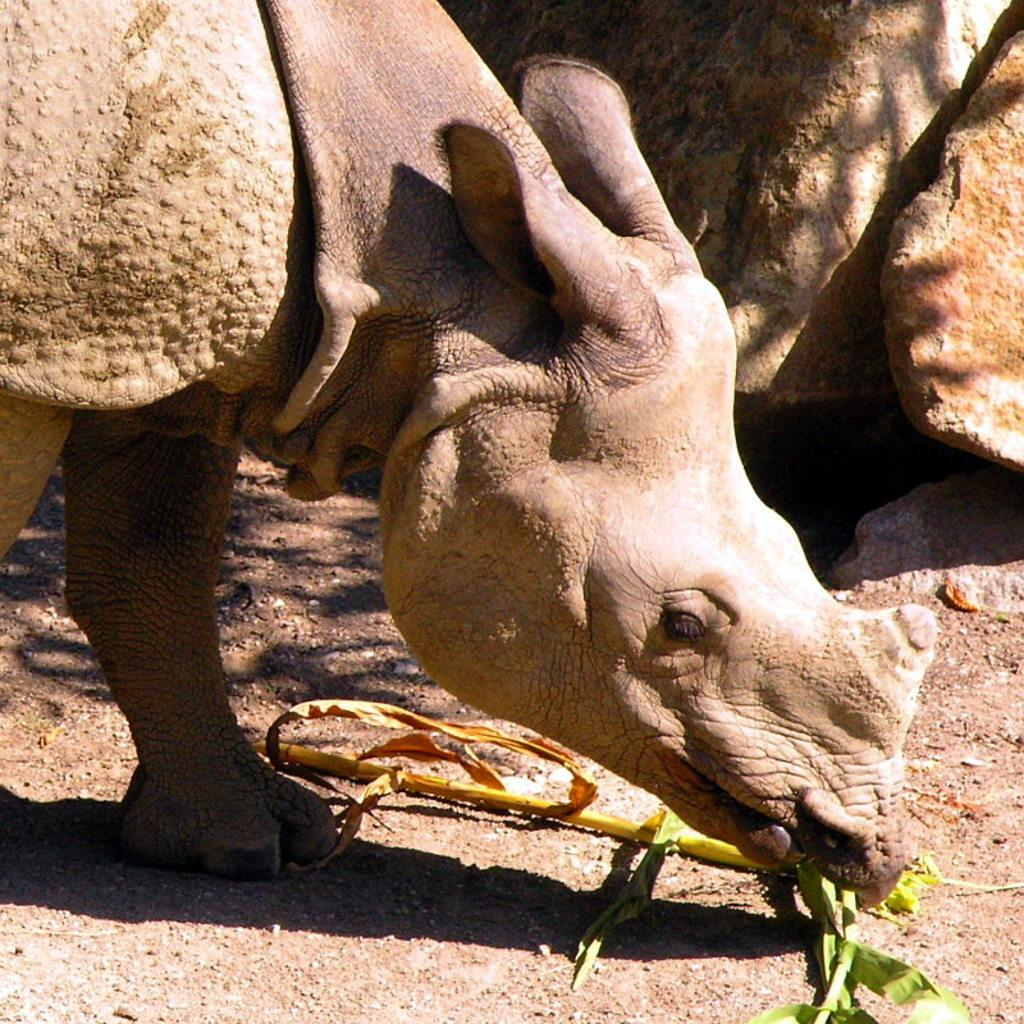What animal can be seen in the image? There is a rhino in the image. What is the rhino doing in the image? The rhino is eating grass in the image. What type of terrain is visible in the background of the image? There are rocks in the background of the image. What surface is the rhino standing on? There is ground visible in the image. What type of cushion is the rhino sitting on in the image? There is no cushion present in the image; the rhino is standing on the ground. How is the wax being used in the image? There is no wax present in the image. 